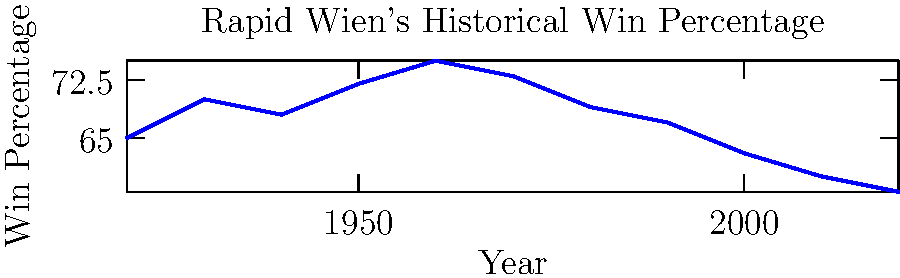Based on the line graph showing Rapid Wien's historical win percentage over time, in which decade did the club experience its peak performance? To determine the decade with Rapid Wien's peak performance, we need to analyze the win percentage trend:

1. The graph shows win percentages from 1920 to 2020.
2. We observe that the line rises from 1920 to 1960, then gradually declines.
3. The highest point on the graph corresponds to the year 1960, with a win percentage of approximately 75%.
4. This indicates that the decade from 1950 to 1960 saw the highest win percentage.
5. Therefore, the 1950s was the decade when Rapid Wien experienced its peak performance.
Answer: 1950s 